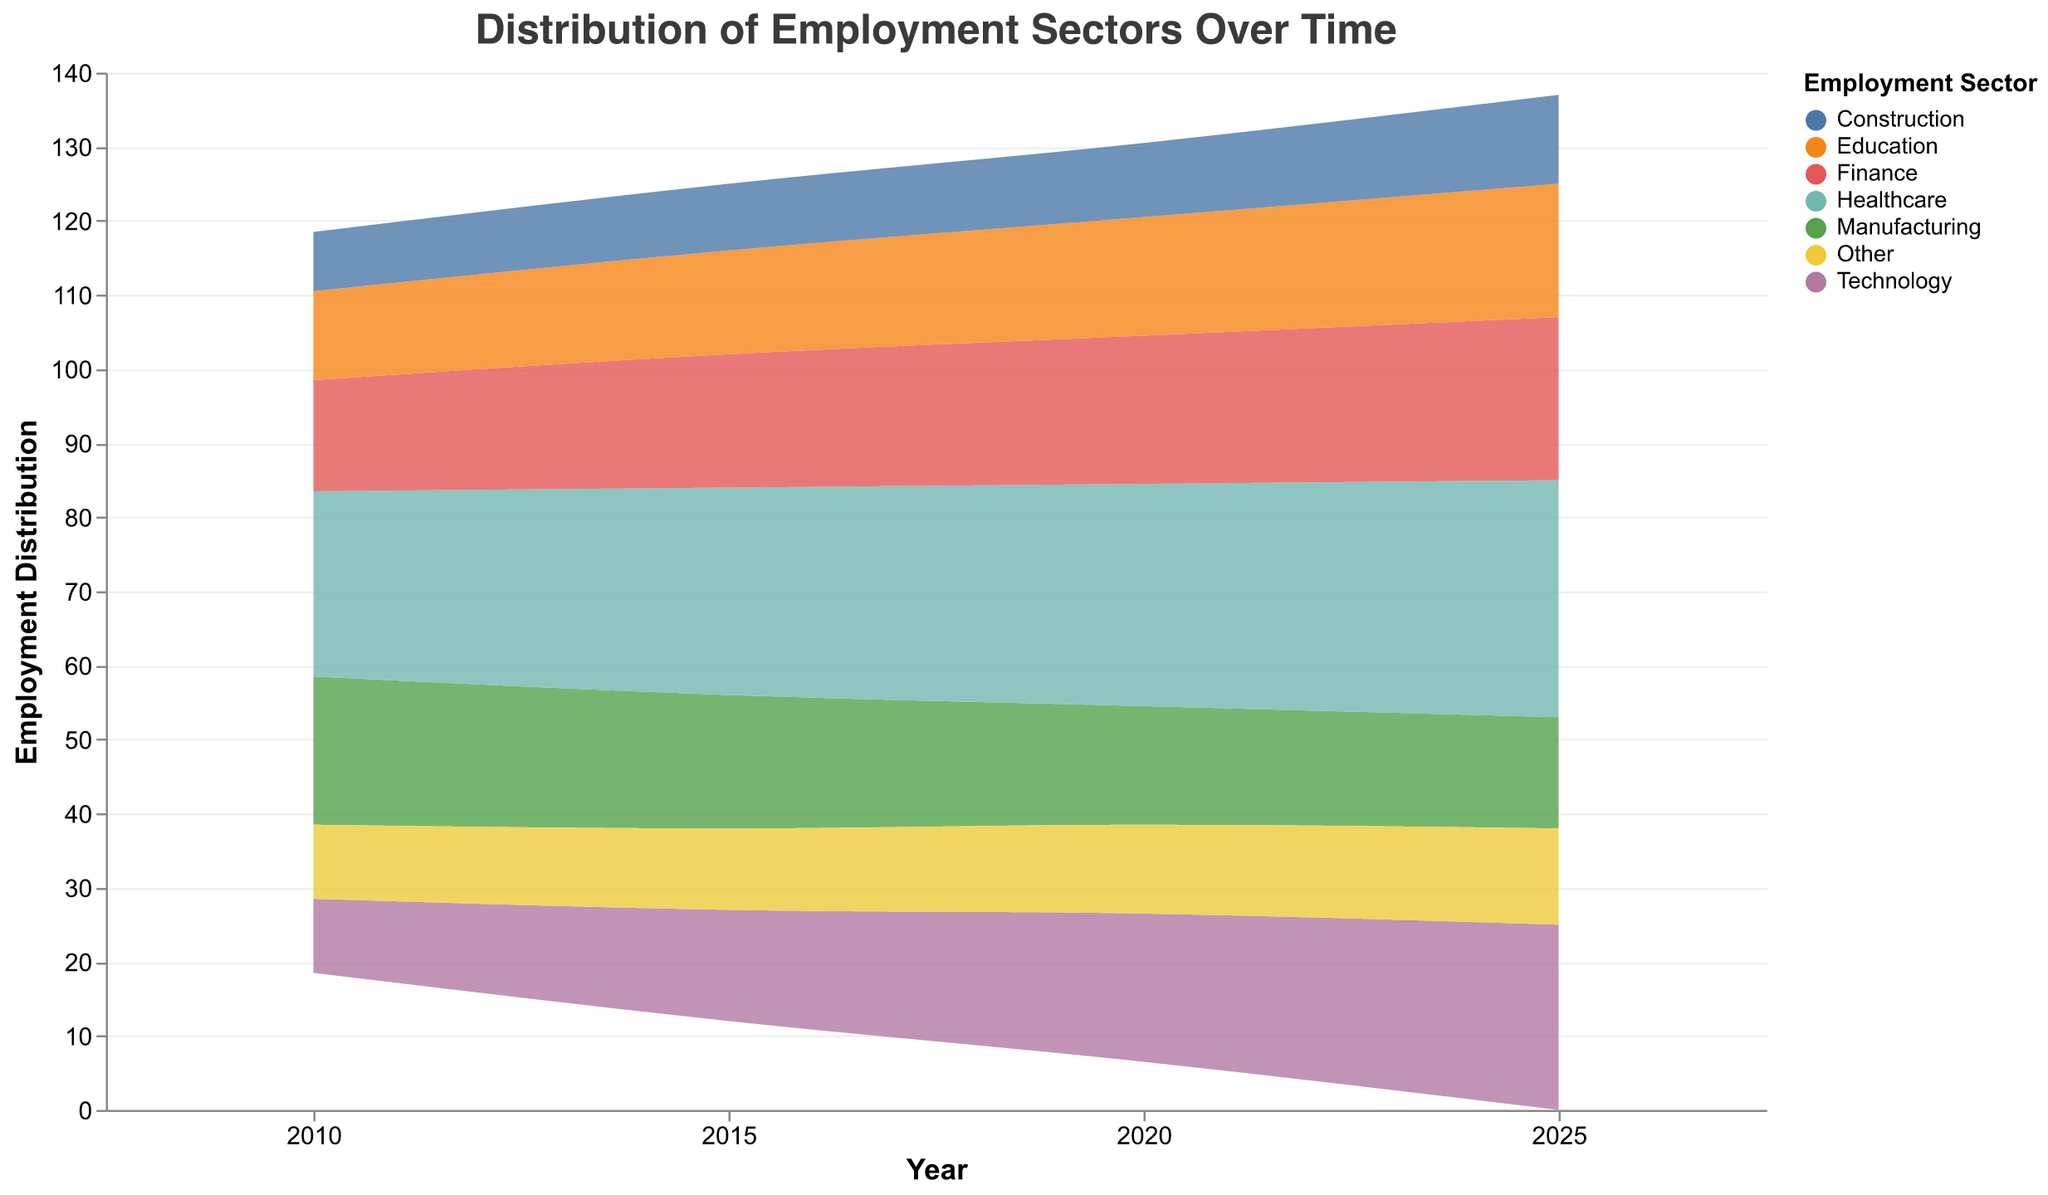What is the title of the figure? The title can be found at the top of the figure. It summarizes what the figure illustrates.
Answer: Distribution of Employment Sectors Over Time Which employment sector has the highest distribution in 2025? By looking at the y-axis and comparing the different sectors in 2025, the sector occupying the highest portion is visible.
Answer: Healthcare How has the distribution of the Technology sector changed from 2010 to 2025? Compare the size of the area representing the Technology sector in 2010 and 2025 to see if it has increased or decreased.
Answer: Increased What is the sum of distributions for Manufacturing and Finance in 2020? Observe the y-axis values for Manufacturing and Finance in 2020 and add them together. Manufacturing is around 16, and Finance is around 20. Sum: 16 + 20.
Answer: 36 Which sector shows a consistent increase in distribution over the years? Look at the trend lines for each sector from 2010 to 2025 to see which one continually rises.
Answer: Healthcare In which year did the Construction sector have the lowest distribution? Find the year where the area corresponding to the Construction sector is the smallest.
Answer: 2010 How does the distribution of the Education sector in 2015 compare to that in 2020? Compare the area sizes of the Education sector for the years 2015 and 2020 to determine which one is larger.
Answer: The distribution is smaller in 2015 than in 2020 What is the difference in distribution for the Other sector between 2010 and 2025? Compare the y-axis values indicating the size of the 'Other' sector in 2010 and 2025 and calculate the difference. 2025 value: 13, 2010 value: 10. Difference: 13-10.
Answer: 3 Which year sees the largest overall employment distribution in the Healthcare sector? The largest overall distribution is indicated by the tallest portion of the Healthcare area in the respective year.
Answer: 2025 If you add the distributions of the Healthcare and Technology sectors for 2020, what is the result? Sum the distributions of Healthcare (30) and Technology (20) sectors for the year 2020.
Answer: 50 